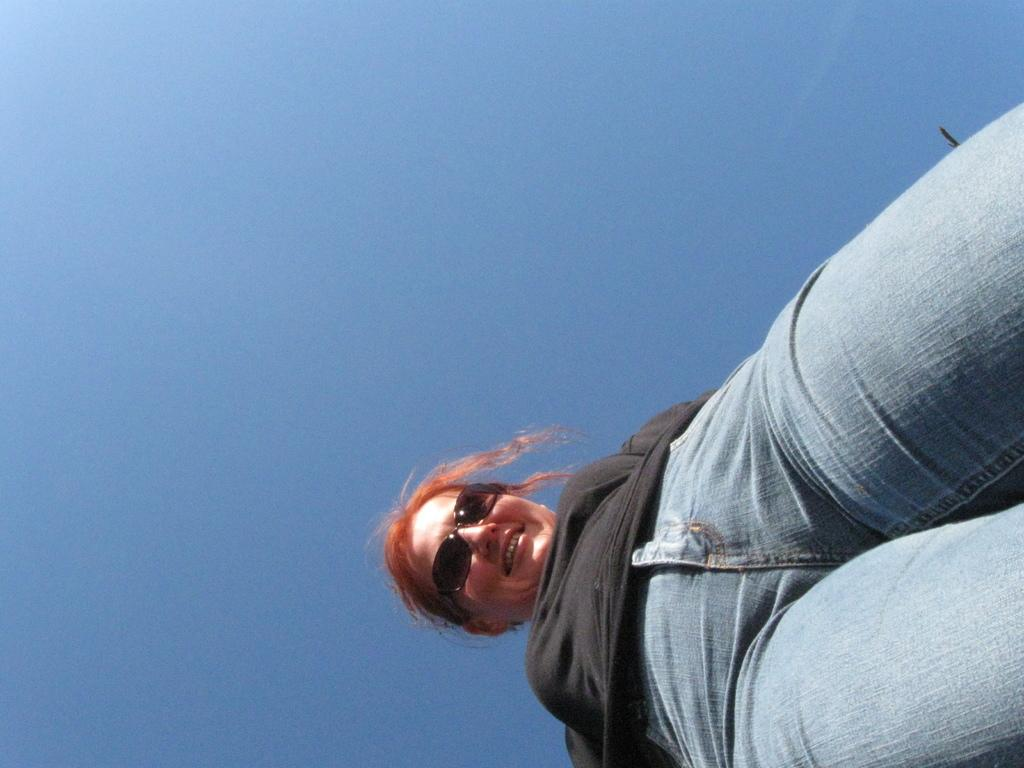Who is present in the image? There is a woman in the image. What is the woman's facial expression? The woman is smiling. What accessory is the woman wearing? The woman is wearing spectacles. What type of badge is the woman wearing in the image? There is no badge visible in the image. What is the woman standing on the edge of in the image? There is no indication of the woman standing on an edge in the image. 